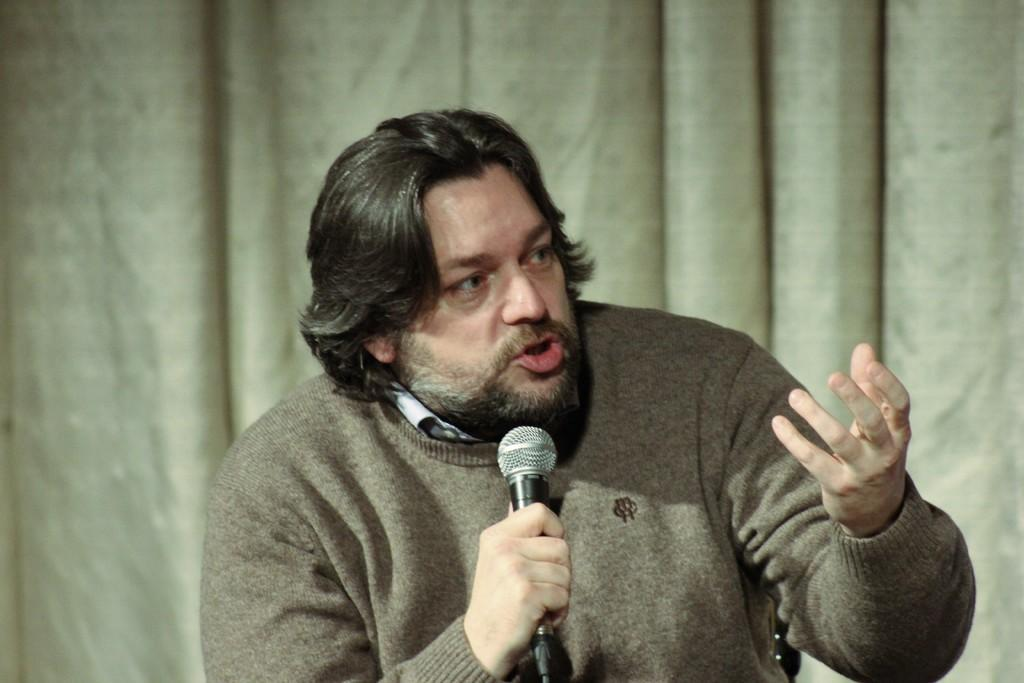Who is present in the image? There is a man in the image. What is the man holding in the image? The man is holding a microphone. What can be seen in the background of the image? There is a curtain in the background of the image. What type of pancake is being prepared on the plough in the image? There is no pancake or plough present in the image. What musical instrument is the man playing in the image? The image does not show the man playing any musical instrument. 